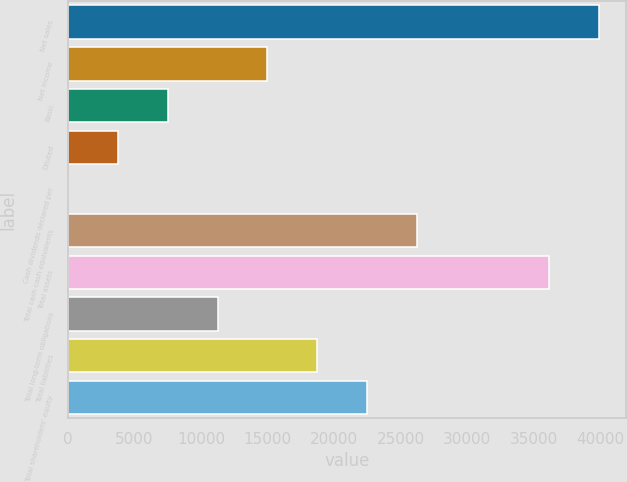Convert chart. <chart><loc_0><loc_0><loc_500><loc_500><bar_chart><fcel>Net sales<fcel>Net income<fcel>Basic<fcel>Diluted<fcel>Cash dividends declared per<fcel>Total cash cash equivalents<fcel>Total assets<fcel>Total long-term obligations<fcel>Total liabilities<fcel>Total shareholders' equity<nl><fcel>39919.8<fcel>14998.5<fcel>7500.96<fcel>3752.21<fcel>3.46<fcel>26244.7<fcel>36171<fcel>11249.7<fcel>18747.2<fcel>22496<nl></chart> 